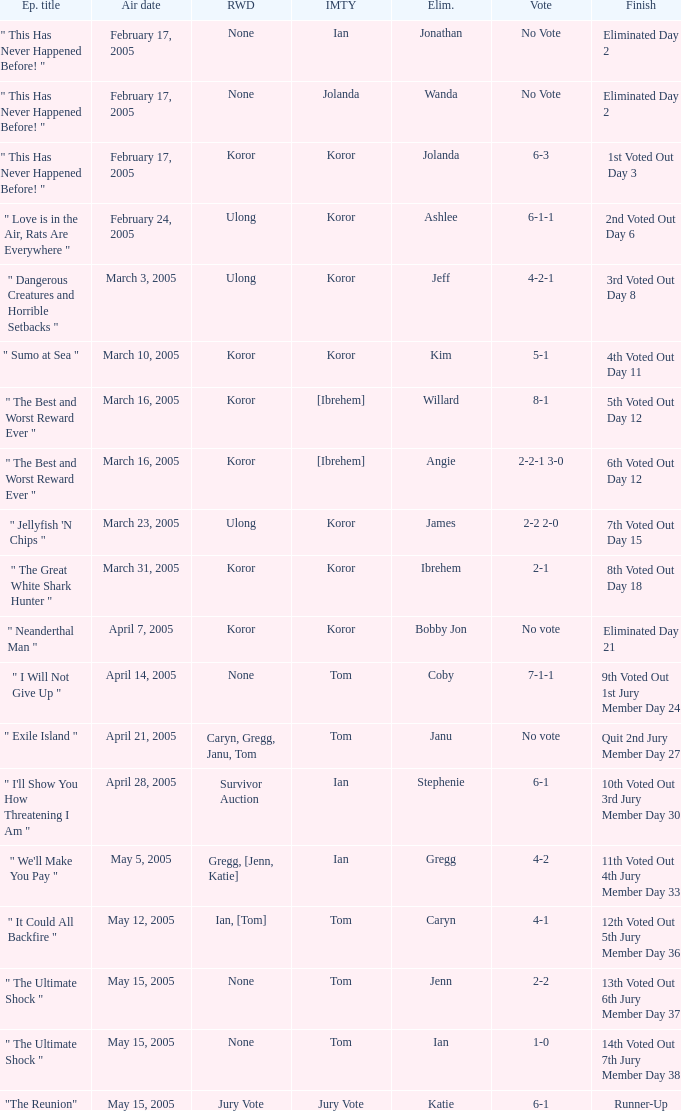How many persons had immunity in the episode when Wanda was eliminated? 1.0. 